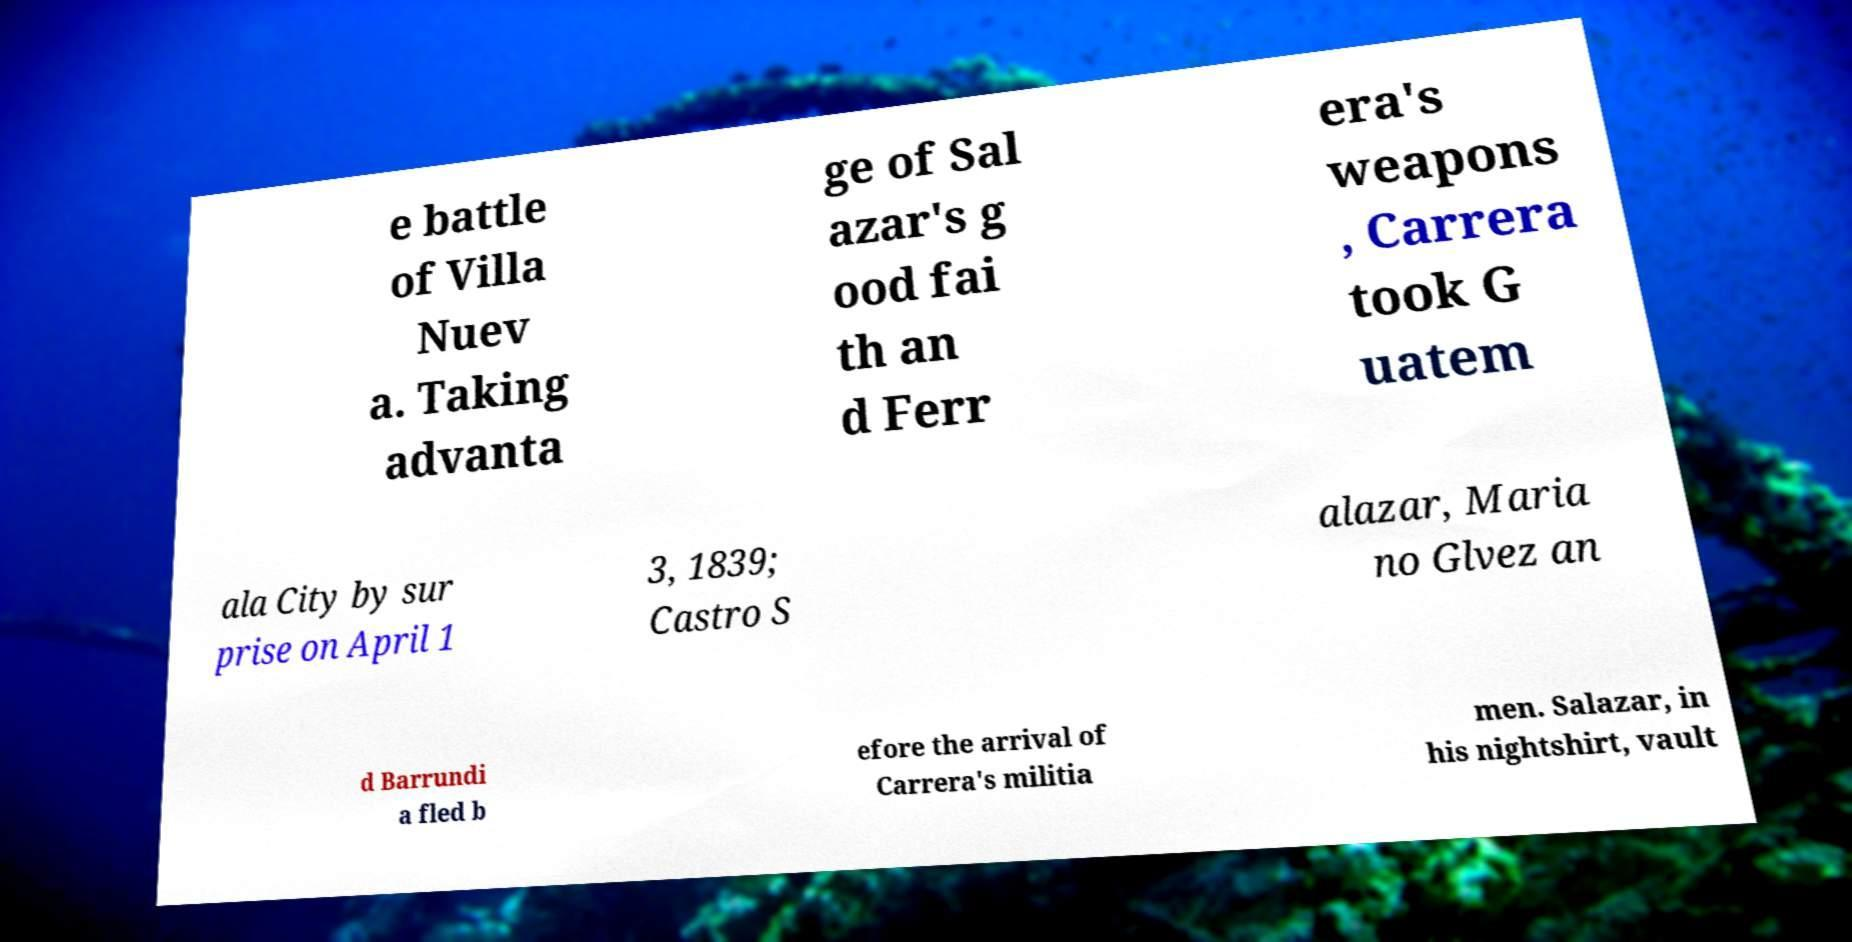What messages or text are displayed in this image? I need them in a readable, typed format. e battle of Villa Nuev a. Taking advanta ge of Sal azar's g ood fai th an d Ferr era's weapons , Carrera took G uatem ala City by sur prise on April 1 3, 1839; Castro S alazar, Maria no Glvez an d Barrundi a fled b efore the arrival of Carrera's militia men. Salazar, in his nightshirt, vault 